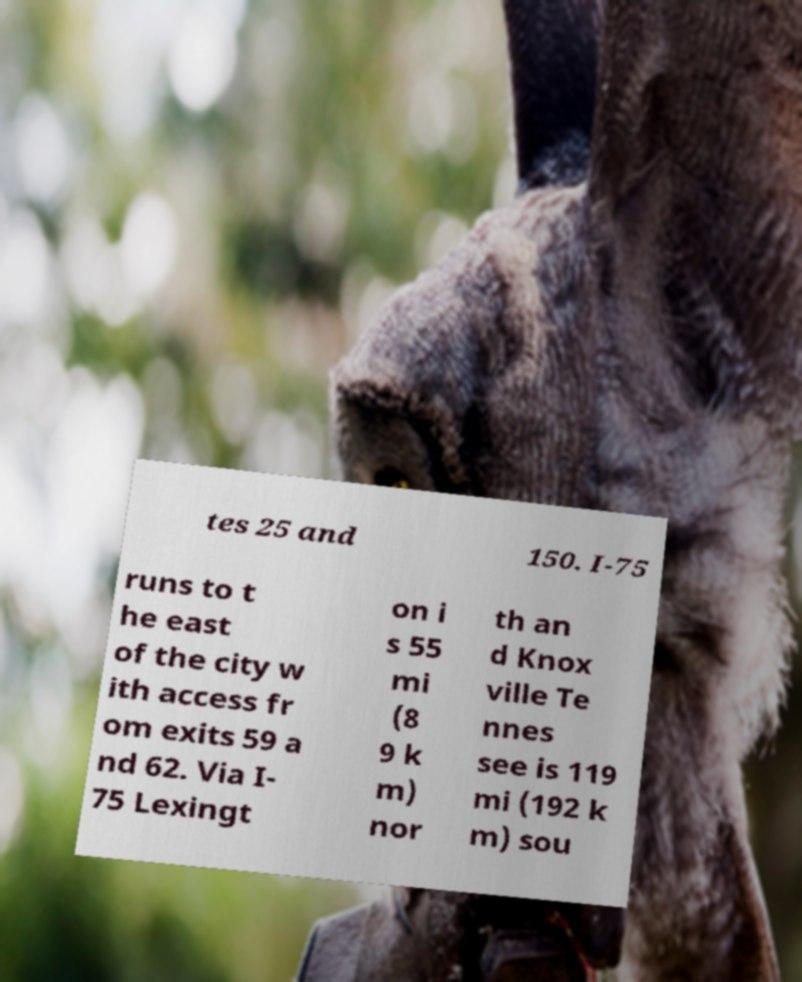Please read and relay the text visible in this image. What does it say? tes 25 and 150. I-75 runs to t he east of the city w ith access fr om exits 59 a nd 62. Via I- 75 Lexingt on i s 55 mi (8 9 k m) nor th an d Knox ville Te nnes see is 119 mi (192 k m) sou 